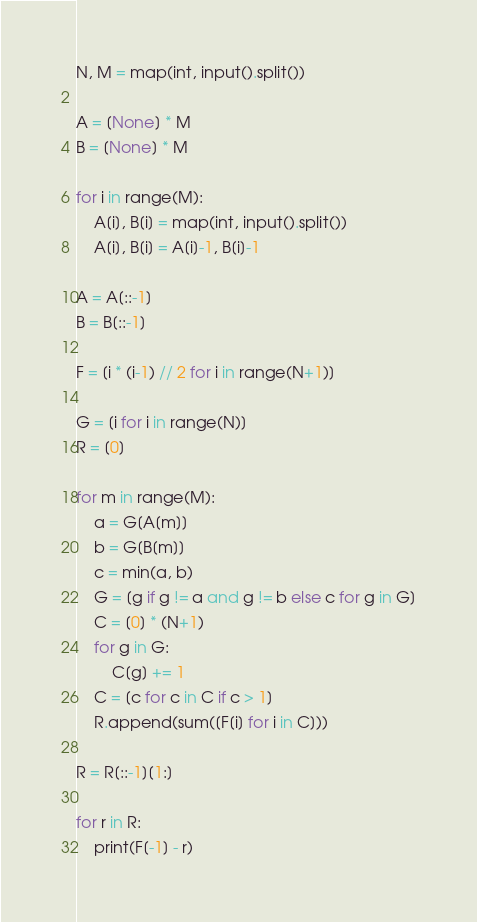<code> <loc_0><loc_0><loc_500><loc_500><_Python_>N, M = map(int, input().split())

A = [None] * M
B = [None] * M

for i in range(M):
    A[i], B[i] = map(int, input().split())
    A[i], B[i] = A[i]-1, B[i]-1

A = A[::-1]
B = B[::-1]

F = [i * (i-1) // 2 for i in range(N+1)]

G = [i for i in range(N)]
R = [0]

for m in range(M):
    a = G[A[m]]
    b = G[B[m]]
    c = min(a, b)
    G = [g if g != a and g != b else c for g in G]
    C = [0] * (N+1)
    for g in G:
        C[g] += 1
    C = [c for c in C if c > 1]
    R.append(sum([F[i] for i in C]))

R = R[::-1][1:]

for r in R:
    print(F[-1] - r)
</code> 